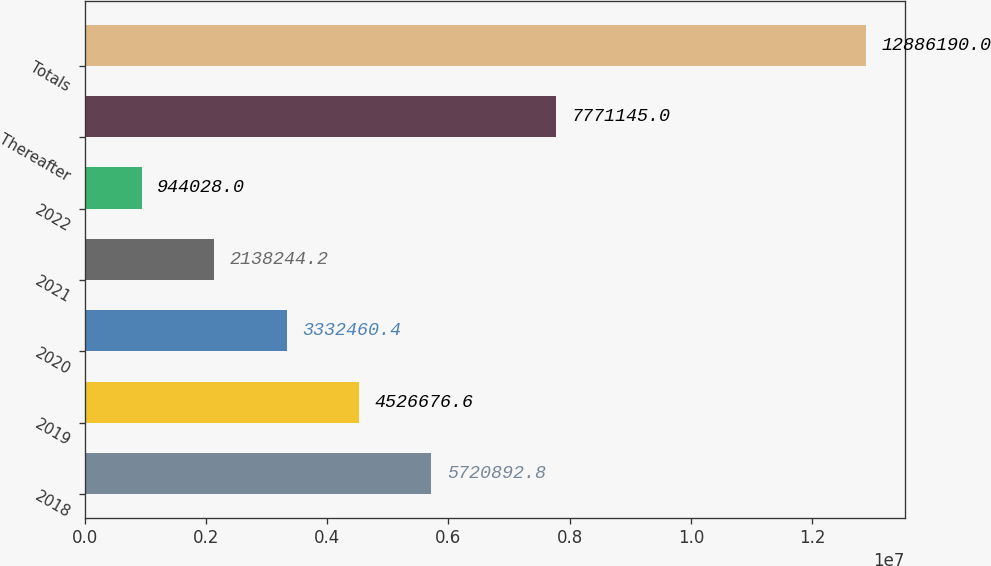Convert chart to OTSL. <chart><loc_0><loc_0><loc_500><loc_500><bar_chart><fcel>2018<fcel>2019<fcel>2020<fcel>2021<fcel>2022<fcel>Thereafter<fcel>Totals<nl><fcel>5.72089e+06<fcel>4.52668e+06<fcel>3.33246e+06<fcel>2.13824e+06<fcel>944028<fcel>7.77114e+06<fcel>1.28862e+07<nl></chart> 